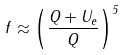<formula> <loc_0><loc_0><loc_500><loc_500>f \approx \left ( \frac { Q + U _ { e } } { Q } \right ) ^ { 5 }</formula> 